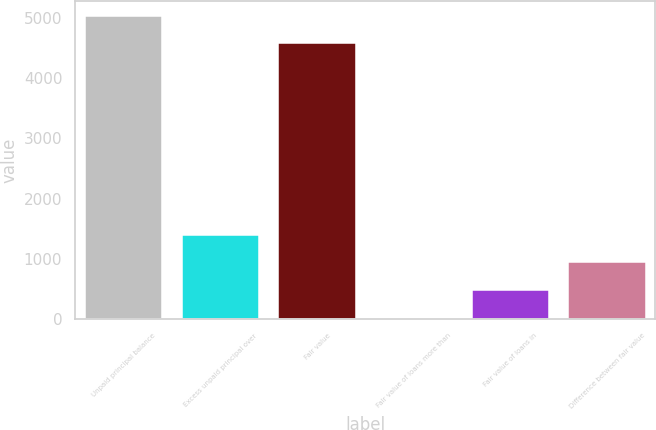<chart> <loc_0><loc_0><loc_500><loc_500><bar_chart><fcel>Unpaid principal balance<fcel>Excess unpaid principal over<fcel>Fair value<fcel>Fair value of loans more than<fcel>Fair value of loans in<fcel>Difference between fair value<nl><fcel>5032.5<fcel>1404.5<fcel>4572<fcel>23<fcel>483.5<fcel>944<nl></chart> 